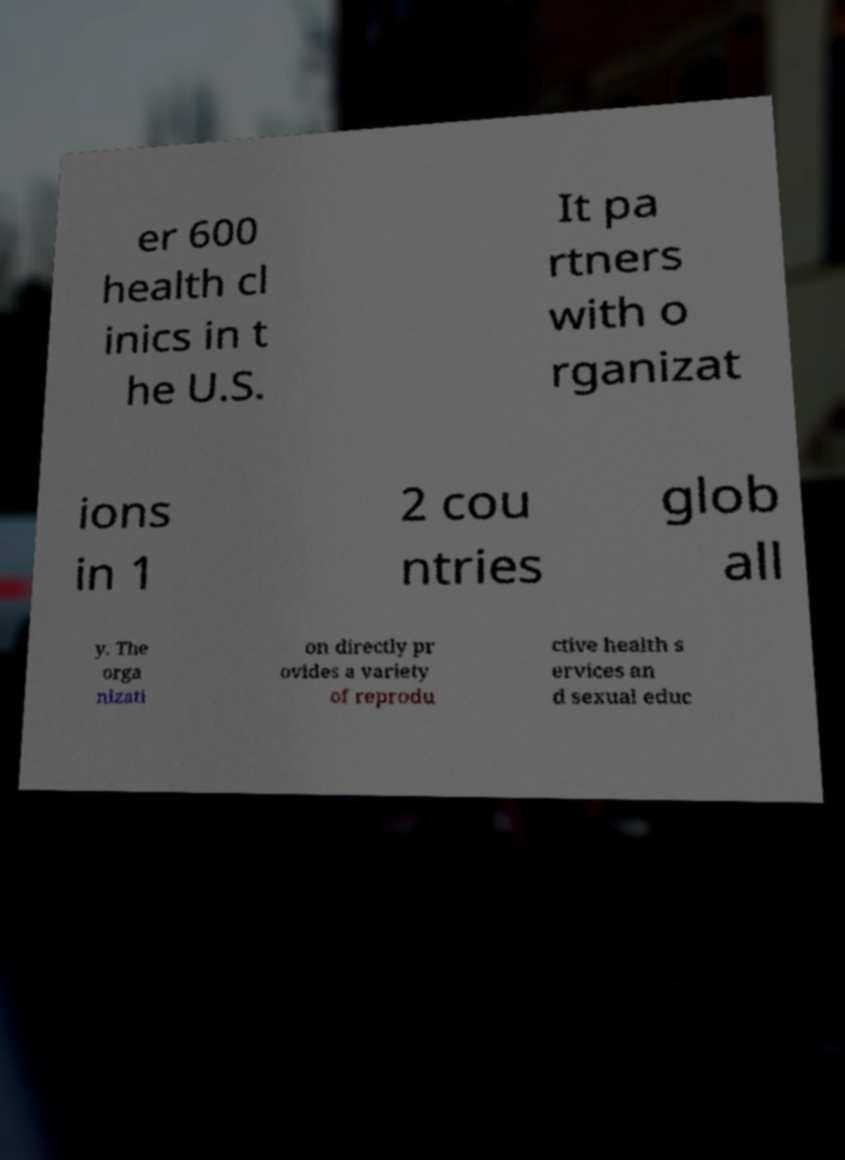Could you extract and type out the text from this image? er 600 health cl inics in t he U.S. It pa rtners with o rganizat ions in 1 2 cou ntries glob all y. The orga nizati on directly pr ovides a variety of reprodu ctive health s ervices an d sexual educ 